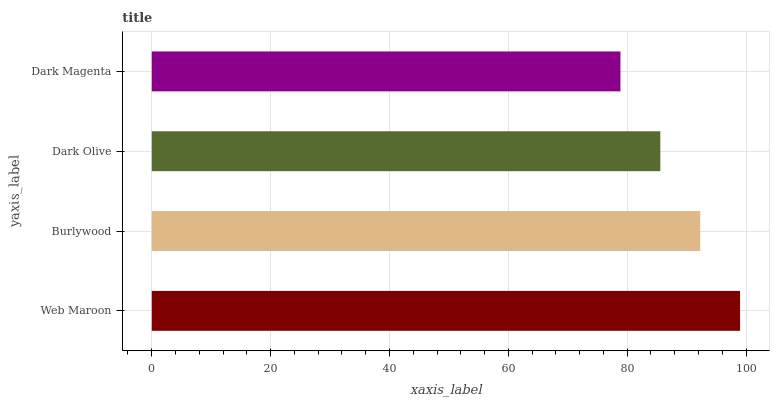Is Dark Magenta the minimum?
Answer yes or no. Yes. Is Web Maroon the maximum?
Answer yes or no. Yes. Is Burlywood the minimum?
Answer yes or no. No. Is Burlywood the maximum?
Answer yes or no. No. Is Web Maroon greater than Burlywood?
Answer yes or no. Yes. Is Burlywood less than Web Maroon?
Answer yes or no. Yes. Is Burlywood greater than Web Maroon?
Answer yes or no. No. Is Web Maroon less than Burlywood?
Answer yes or no. No. Is Burlywood the high median?
Answer yes or no. Yes. Is Dark Olive the low median?
Answer yes or no. Yes. Is Dark Magenta the high median?
Answer yes or no. No. Is Dark Magenta the low median?
Answer yes or no. No. 